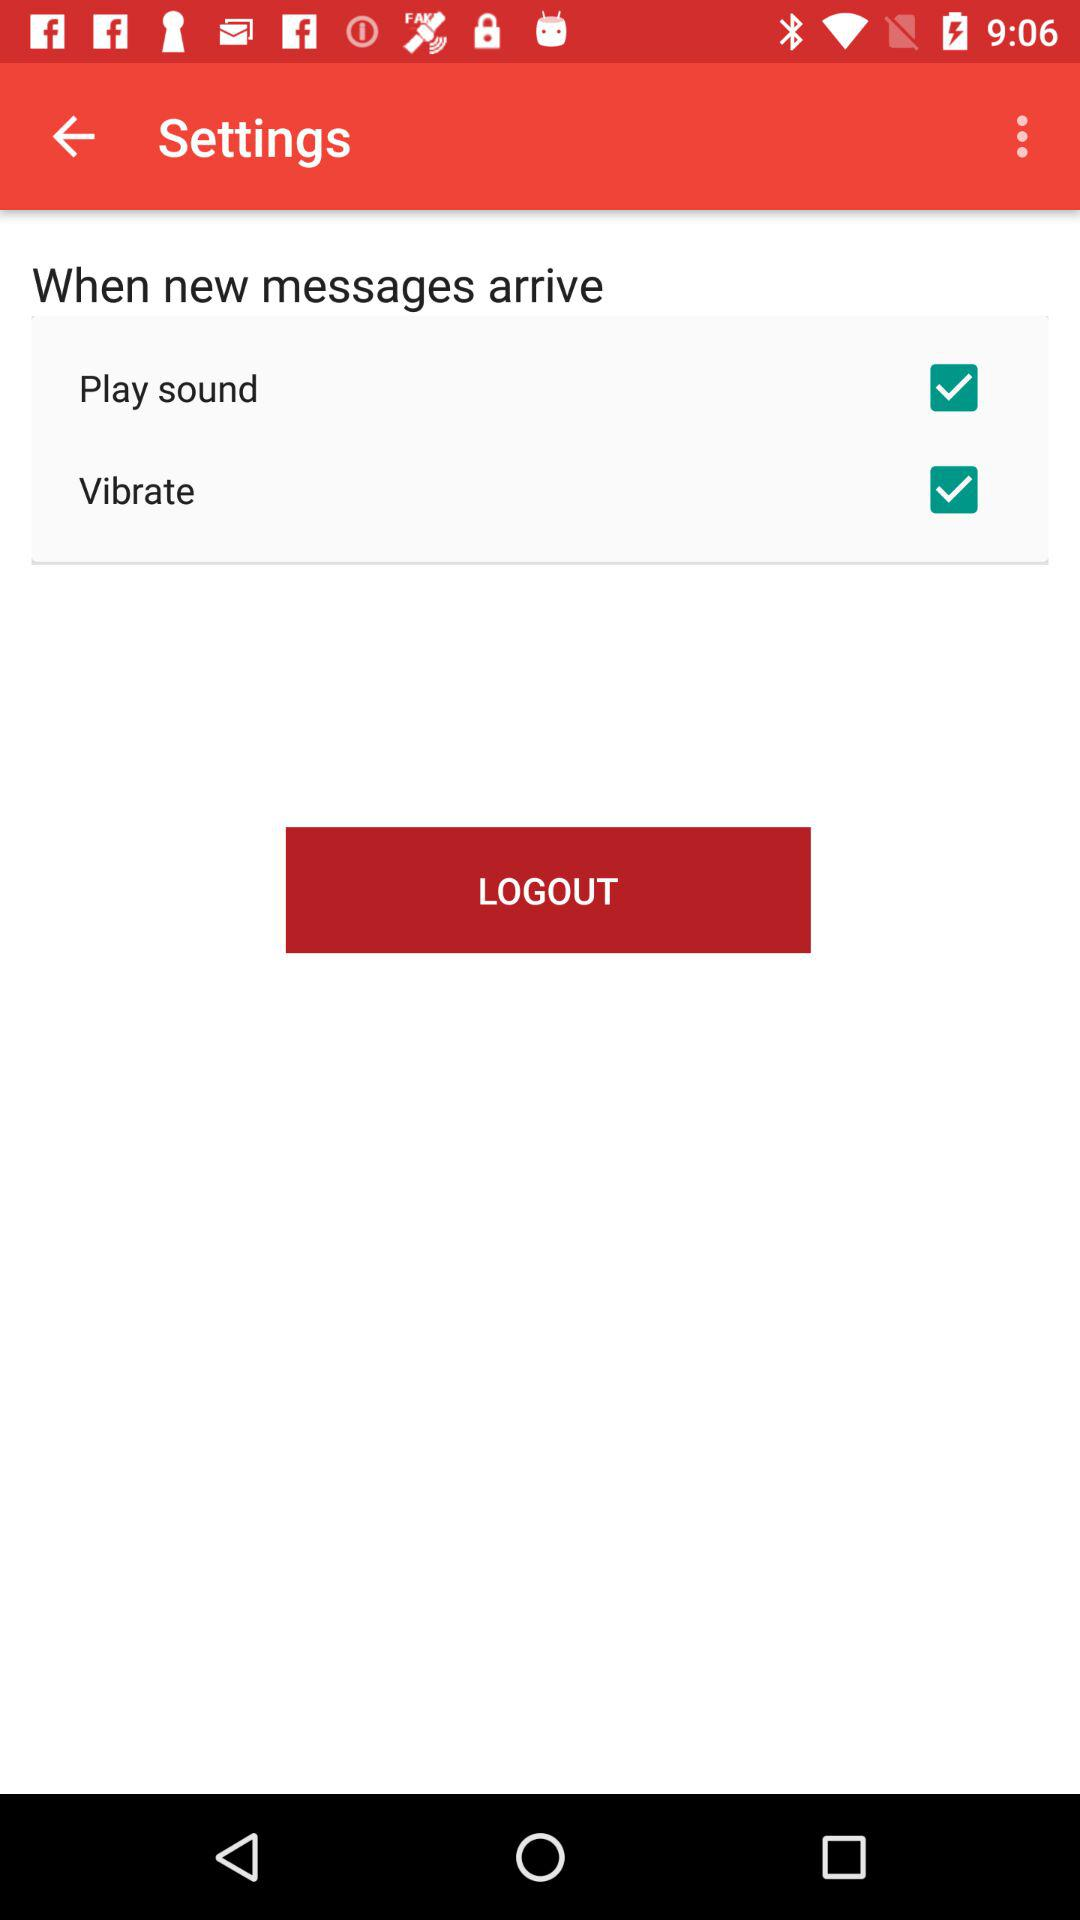What is the checked checkbox in "When new messages arrive"? The checked checkboxes are "Play sound" and "Vibrate". 